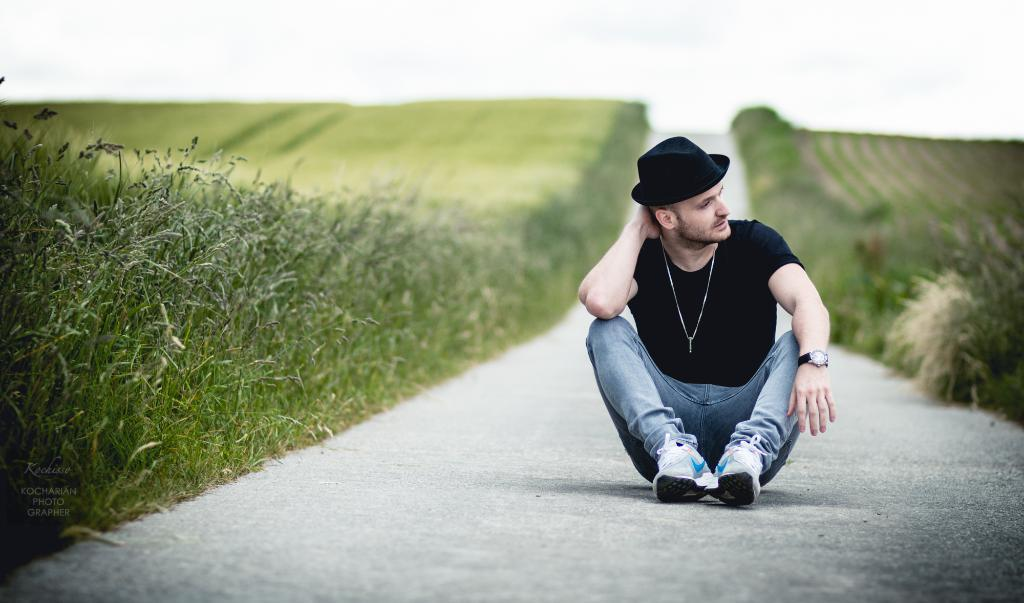What is the man in the image doing? The man is sitting on a road in the image. Can you describe the man's attire? The man is wearing a cap, a watch, and a chain. What can be seen on either side of the road? There are plants on either side of the road. What is visible at the top of the image? The sky is visible at the top of the image. What type of boot is the man wearing on his head in the image? There is no boot present on the man's head in the image. Can you tell me the time displayed on the clock in the image? There is no clock present in the image. 